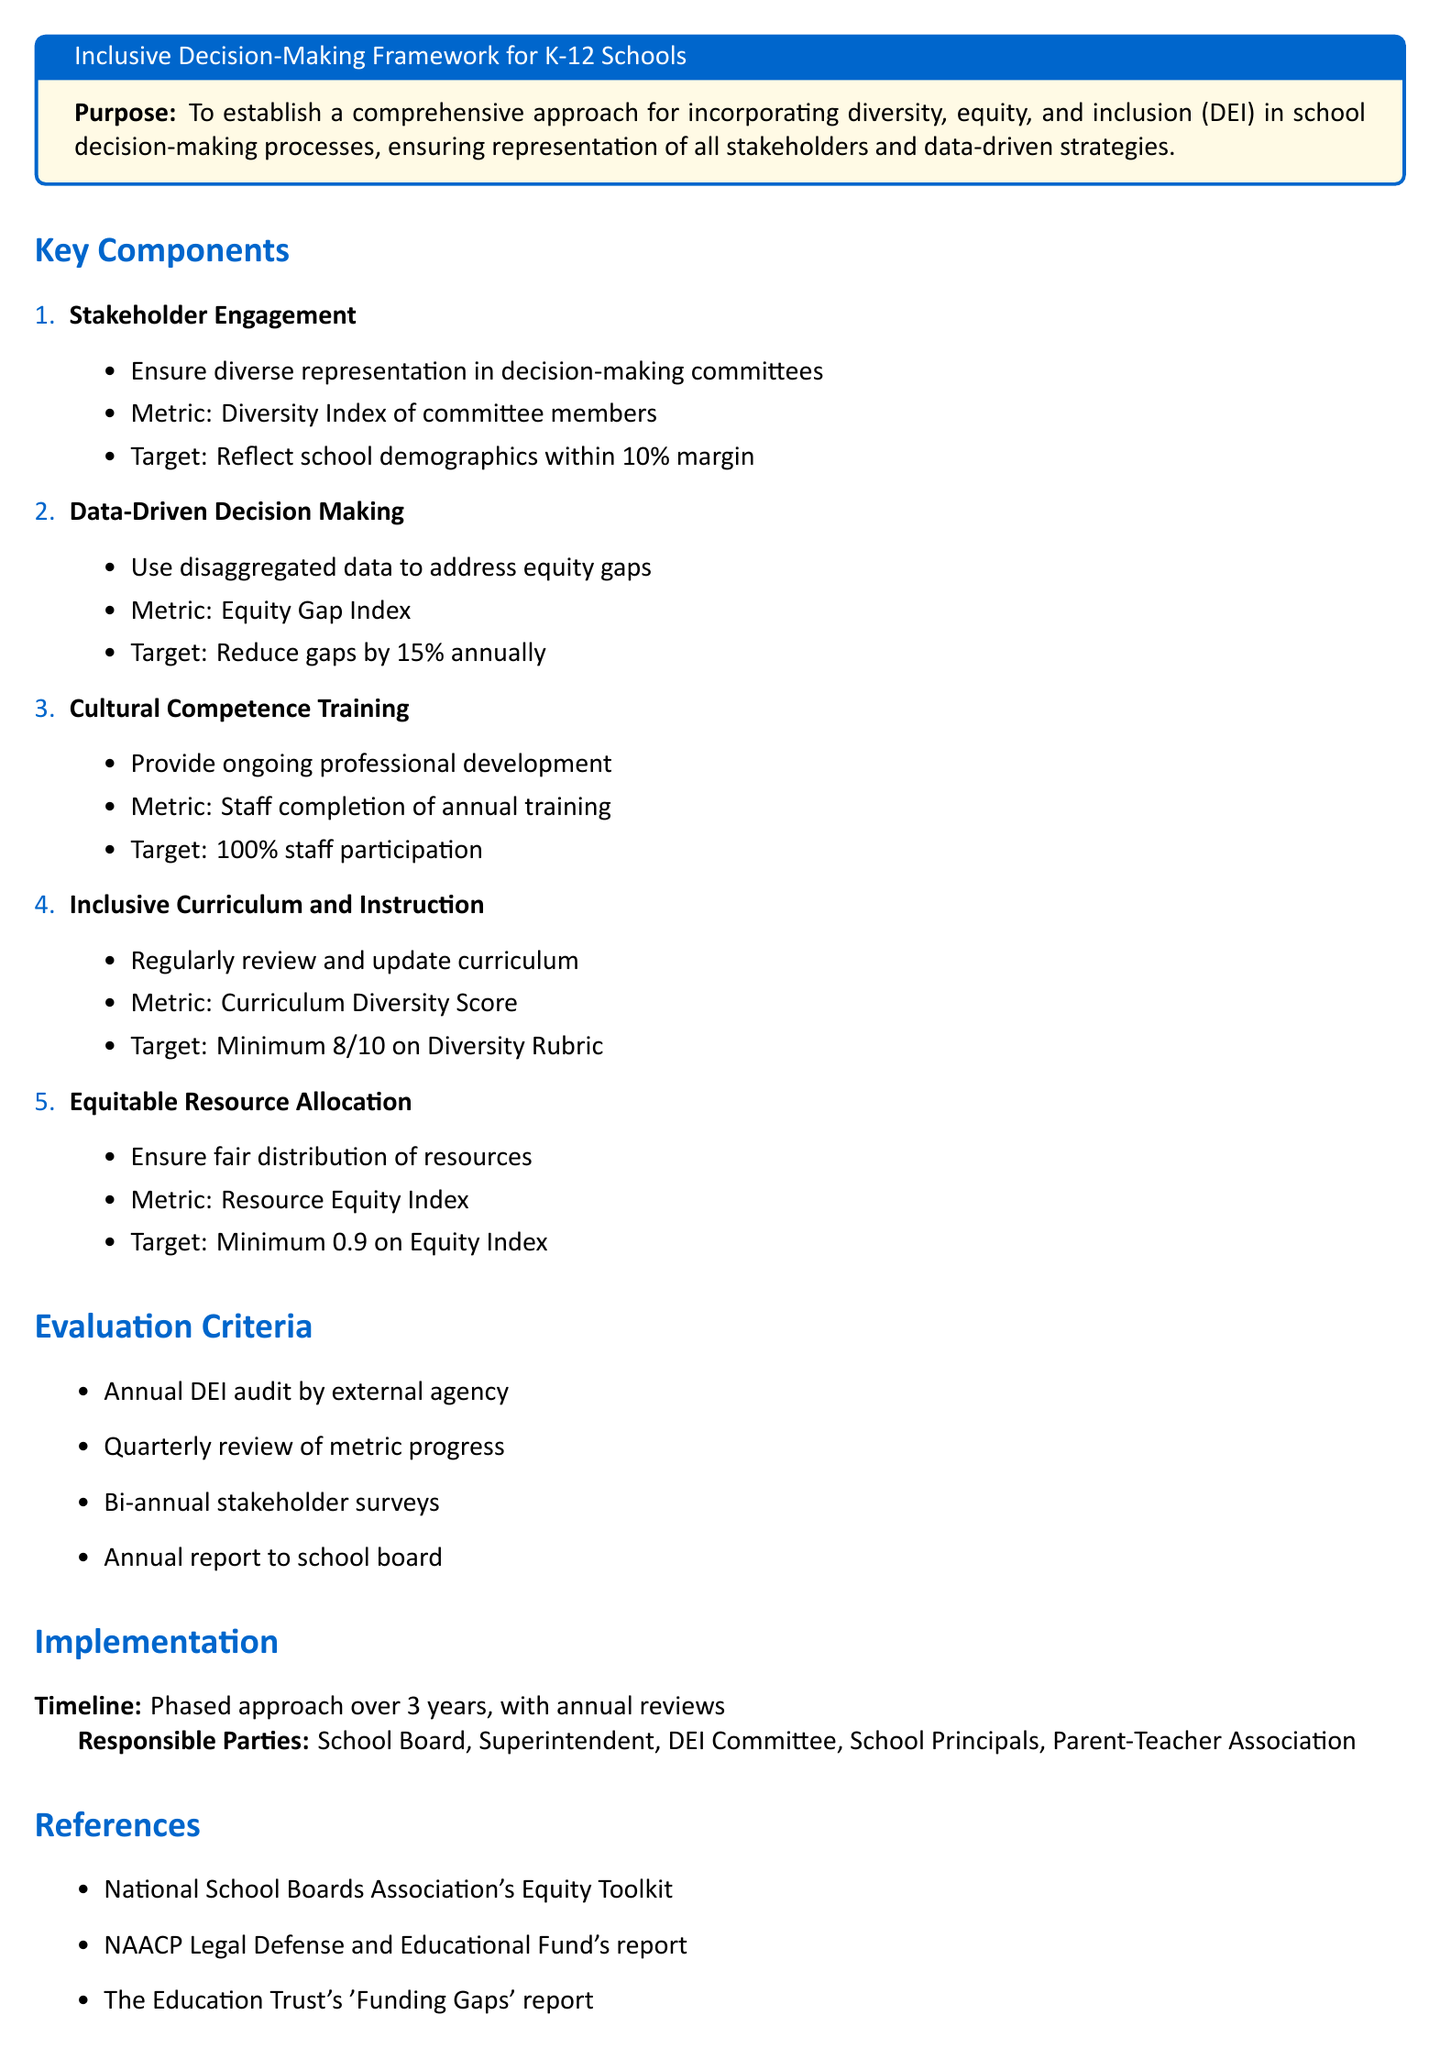What is the purpose of the document? The purpose is to establish a comprehensive approach for incorporating diversity, equity, and inclusion in school decision-making processes.
Answer: To establish a comprehensive approach for incorporating diversity, equity, and inclusion in school decision-making processes What is the target for the Diversity Index of committee members? The document states that the target for the Diversity Index should reflect school demographics within a 10% margin.
Answer: Reflect school demographics within 10% margin What is the target reduction for the Equity Gap Index annually? The target reduction specified in the document is 15% annually.
Answer: Reduce gaps by 15% annually What score is required for the Curriculum Diversity Score? The document states that the minimum required score on the Diversity Rubric is 8 out of 10.
Answer: Minimum 8/10 on Diversity Rubric What is the timeline for implementation? The timeline for implementation mentioned in the document includes a phased approach over 3 years.
Answer: Phased approach over 3 years Who is responsible for the annual DEI audit? An external agency is responsible for conducting the annual DEI audit as stated in the document.
Answer: External agency What is the expected level of staff participation in training? The document specifies that the target for staff completion of annual training is 100% participation.
Answer: 100% staff participation How often will stakeholder surveys be conducted? According to the document, stakeholder surveys will be conducted bi-annually.
Answer: Bi-annual stakeholder surveys What is included in the evaluation criteria? The evaluation criteria include an annual DEI audit, quarterly review of metrics, bi-annual surveys, and an annual report.
Answer: Annual DEI audit, quarterly review of metric progress, bi-annual stakeholder surveys, annual report to school board 